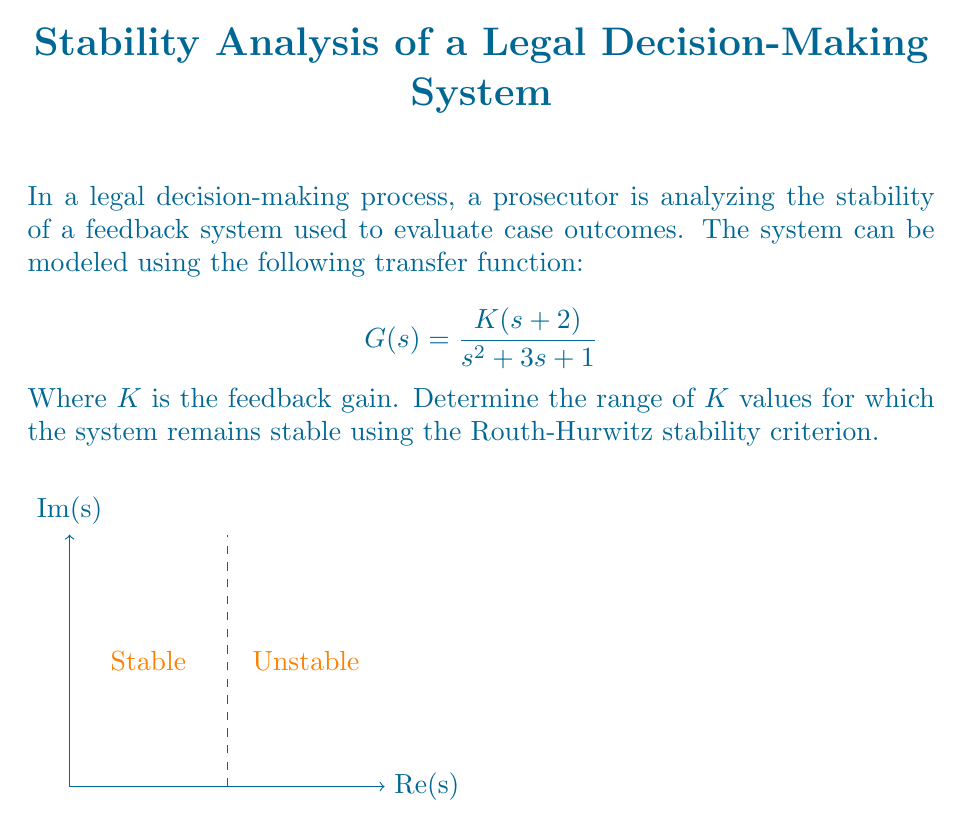What is the answer to this math problem? To analyze the stability of this feedback system, we'll use the Routh-Hurwitz stability criterion:

1) First, we need to form the closed-loop transfer function:
   $$T(s) = \frac{G(s)}{1 + G(s)} = \frac{K(s+2)}{s^2 + 3s + 1 + K(s+2)}$$

2) The characteristic equation is:
   $$s^2 + 3s + 1 + K(s+2) = 0$$
   $$s^2 + (3+K)s + (1+2K) = 0$$

3) Now, we form the Routh array:
   $$\begin{array}{c|cc}
   s^2 & 1 & 1+2K \\
   s^1 & 3+K & 0 \\
   s^0 & 1+2K & 0
   \end{array}$$

4) For stability, all elements in the first column must be positive:
   
   a) $1 > 0$ (always true)
   b) $3+K > 0$, which means $K > -3$
   c) $1+2K > 0$, which means $K > -\frac{1}{2}$

5) Combining these conditions, we get:
   $$K > -\frac{1}{2}$$

This means the system is stable for all values of $K$ greater than $-\frac{1}{2}$.
Answer: $K > -\frac{1}{2}$ 